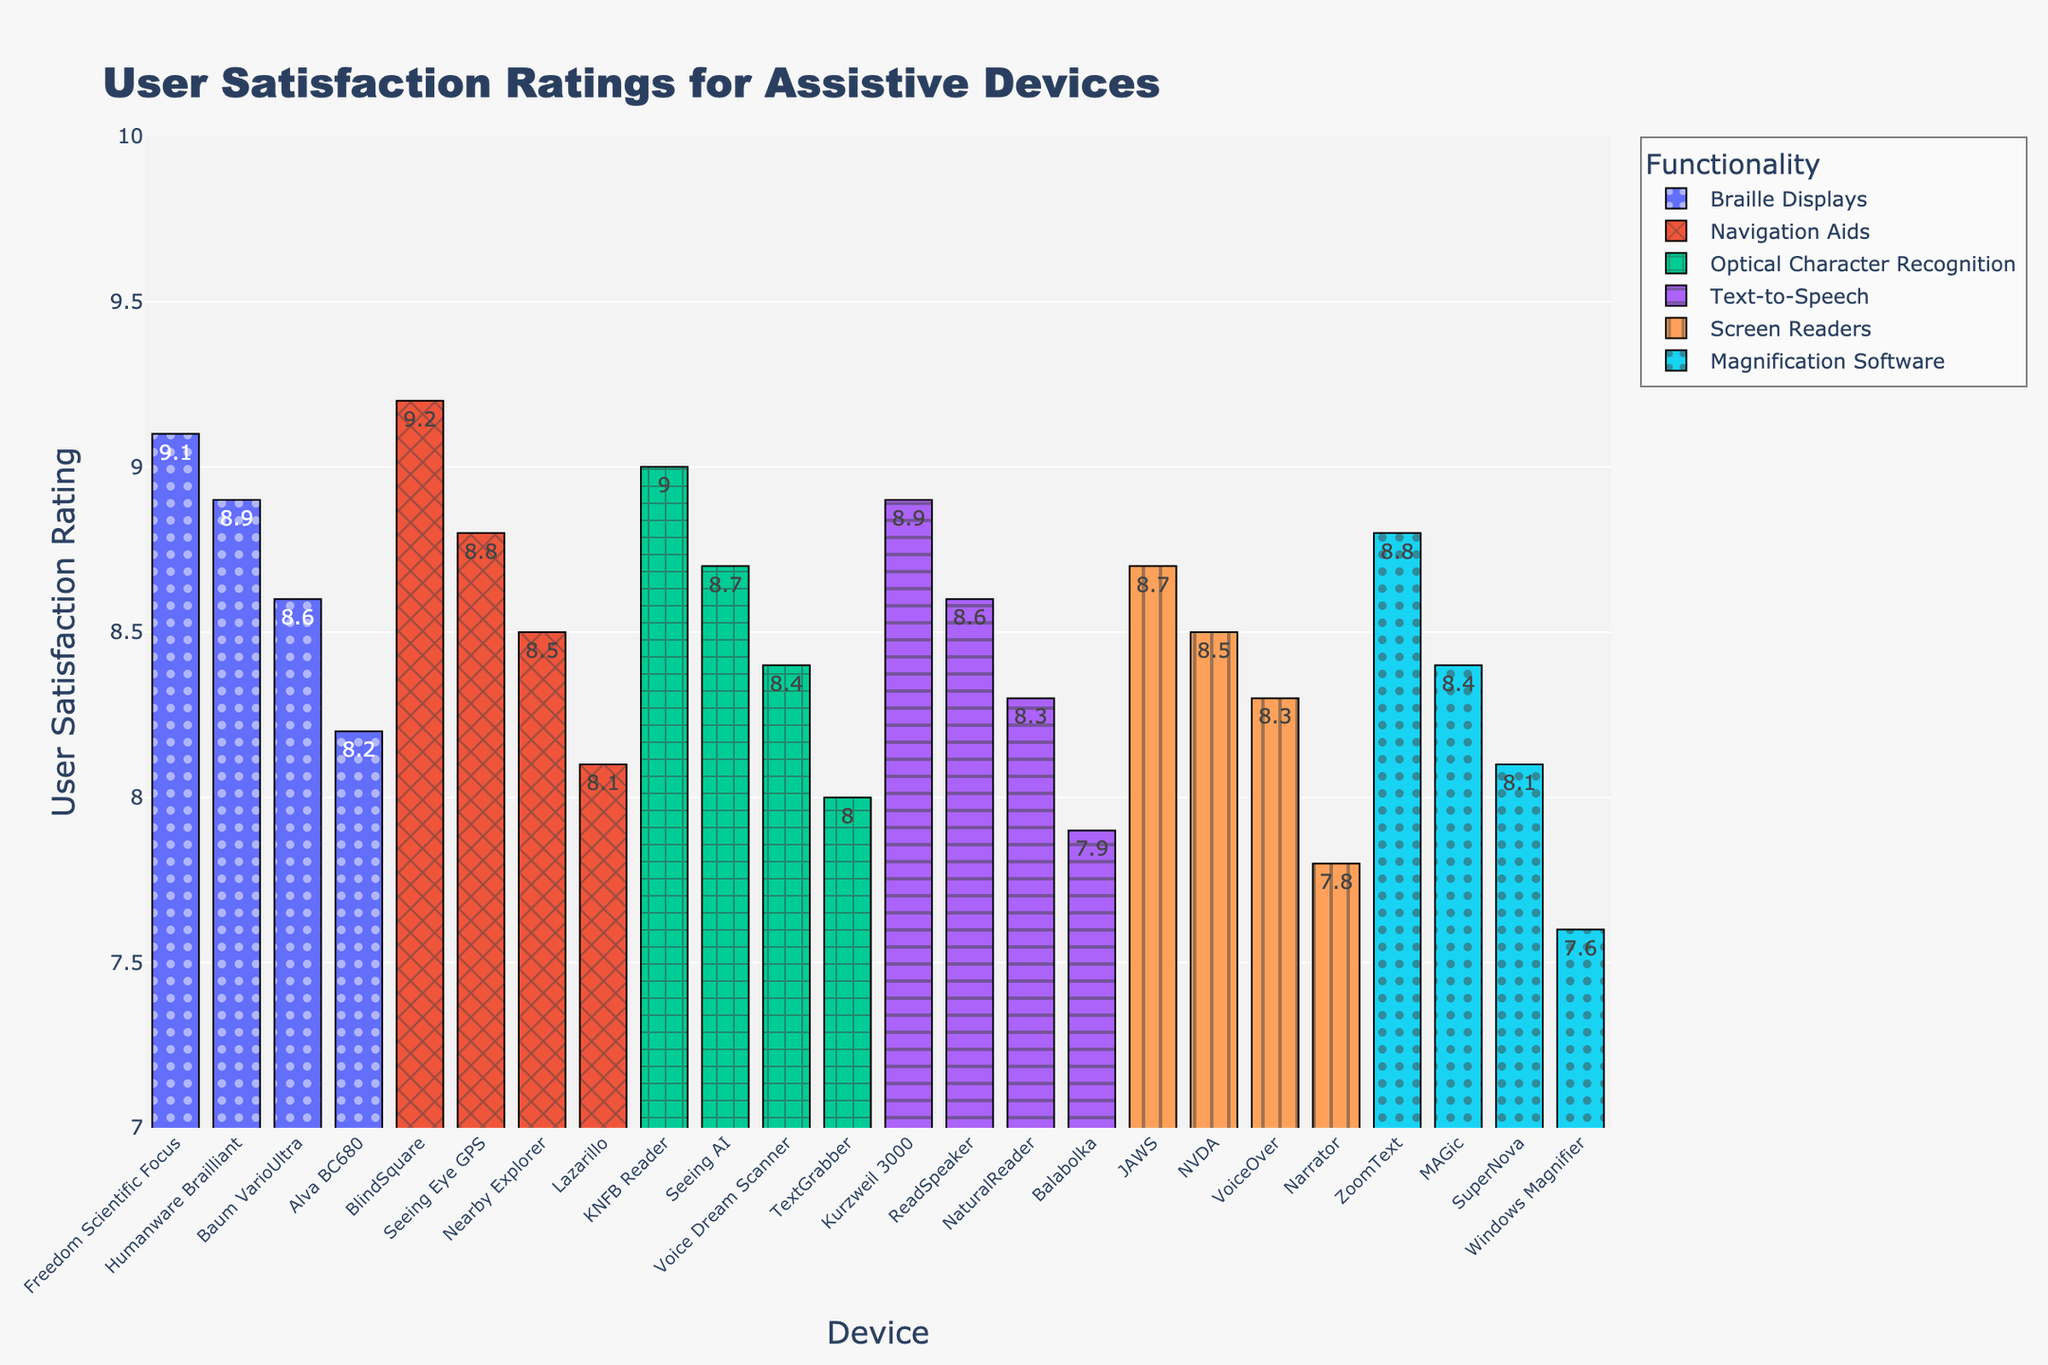Which functionality has the highest average user satisfaction rating? First, calculate the average rating for each functionality: (JAWS + NVDA + VoiceOver + Narrator) / 4 for Screen Readers, (Freedom Scientific Focus + Humanware Brailliant + Baum VarioUltra + Alva BC680) / 4 for Braille Displays, and so on. The functionality with the highest average is Navigation Aids: (9.2 + 8.8 + 8.5 + 8.1) / 4 = 8.65.
Answer: Navigation Aids Which device has the lowest user satisfaction rating in the chart? Examine each bar in the chart for the lowest rating. The device with the lowest rating is Windows Magnifier with a rating of 7.6.
Answer: Windows Magnifier What's the difference between the highest and lowest satisfaction ratings in the 'Screen Readers' category? Identify the highest and lowest ratings in the 'Screen Readers' category. The highest is JAWS with 8.7, and the lowest is Narrator with 7.8. The difference is 8.7 - 7.8 = 0.9.
Answer: 0.9 Among 'Braille Displays' devices, which one has the highest rating? Look at the bars for 'Braille Displays' and find the highest rating. Freedom Scientific Focus has the highest rating of 9.1.
Answer: Freedom Scientific Focus Compare the average user satisfaction ratings between 'Text-to-Speech' and 'Optical Character Recognition' devices. Which category has a higher average rating and by how much? Calculate the average for each category: for 'Text-to-Speech' (8.9 + 8.6 + 8.3 + 7.9) / 4 = 8.425 and for 'Optical Character Recognition' (9 + 8.7 + 8.4 + 8) / 4 = 8.525. The difference is 8.525 - 8.425 = 0.1, so 'Optical Character Recognition' has a higher average rating by 0.1.
Answer: Optical Character Recognition by 0.1 Which device in the 'Navigation Aids' category has the highest user satisfaction rating? Look at the bars for 'Navigation Aids' and find the highest rating. BlindSquare has the highest rating with 9.2.
Answer: BlindSquare How many devices have a user satisfaction rating above 9? Count the number of bars with ratings above 9. There are three devices: Freedom Scientific Focus, BlindSquare, and KNFB Reader.
Answer: 3 What is the mean user satisfaction rating for all devices combined? Sum all the ratings and divide by the number of devices. (8.7 + 8.5 + 8.3 + 7.8 + 9.1 + 8.9 + 8.6 + 8.2 + 8.8 + 8.4 + 8.1 + 7.6 + 8.9 + 8.6 + 8.3 + 7.9 + 9.2 + 8.8 + 8.5 + 8.1 + 9 + 8.7 + 8.4 + 8) / 24 ≈ 8.5.
Answer: 8.5 